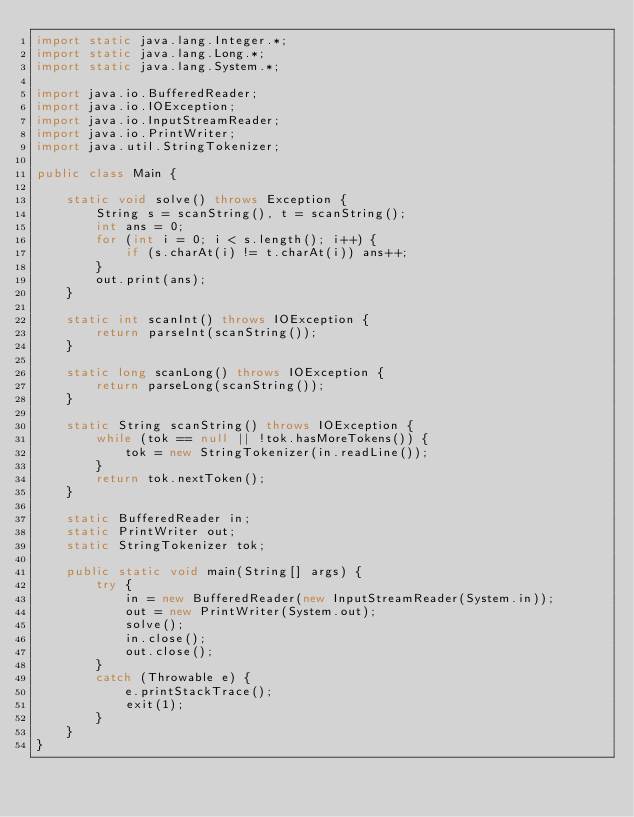Convert code to text. <code><loc_0><loc_0><loc_500><loc_500><_Java_>import static java.lang.Integer.*;
import static java.lang.Long.*;
import static java.lang.System.*;

import java.io.BufferedReader;
import java.io.IOException;
import java.io.InputStreamReader;
import java.io.PrintWriter;
import java.util.StringTokenizer;

public class Main {

    static void solve() throws Exception {
        String s = scanString(), t = scanString();
        int ans = 0;
        for (int i = 0; i < s.length(); i++) {
            if (s.charAt(i) != t.charAt(i)) ans++;
        }
        out.print(ans);
    }

    static int scanInt() throws IOException {
        return parseInt(scanString());
    }

    static long scanLong() throws IOException {
        return parseLong(scanString());
    }

    static String scanString() throws IOException {
        while (tok == null || !tok.hasMoreTokens()) {
            tok = new StringTokenizer(in.readLine());
        }
        return tok.nextToken();
    }

    static BufferedReader in;
    static PrintWriter out;
    static StringTokenizer tok;

    public static void main(String[] args) {
        try {
            in = new BufferedReader(new InputStreamReader(System.in));
            out = new PrintWriter(System.out);
            solve();
            in.close();
            out.close();
        }
        catch (Throwable e) {
            e.printStackTrace();
            exit(1);
        }
    }
}</code> 